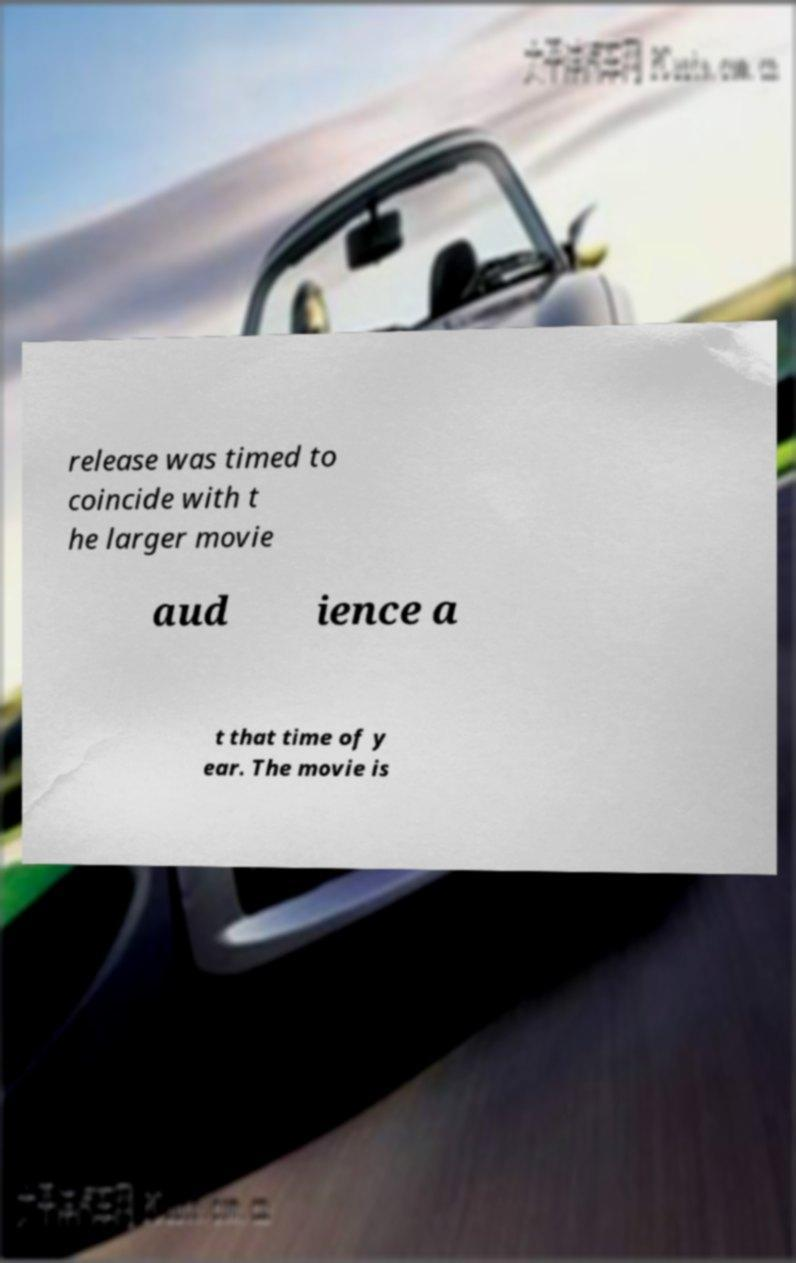For documentation purposes, I need the text within this image transcribed. Could you provide that? release was timed to coincide with t he larger movie aud ience a t that time of y ear. The movie is 